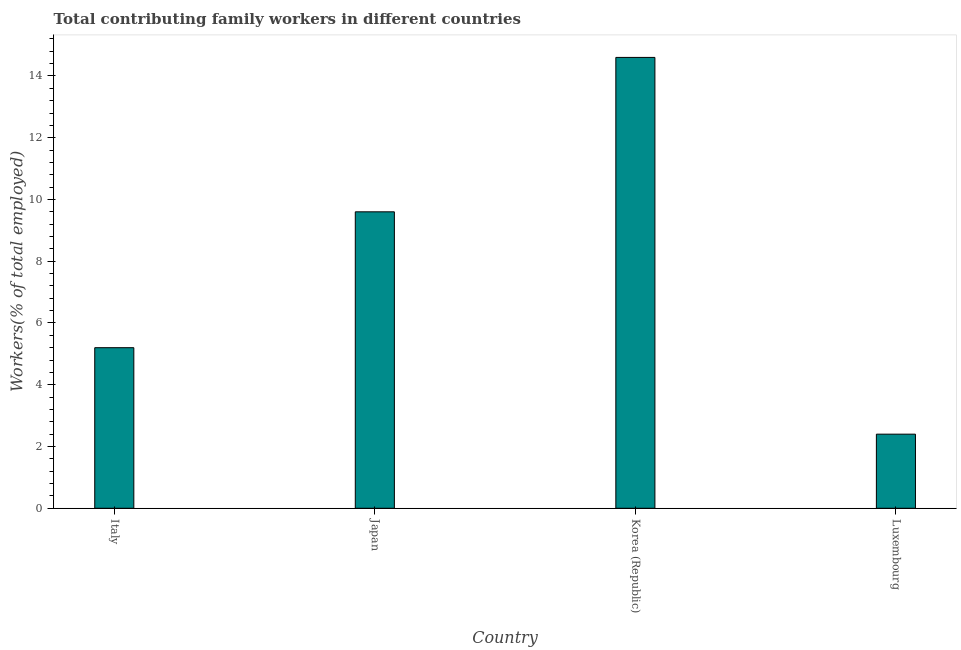Does the graph contain any zero values?
Keep it short and to the point. No. What is the title of the graph?
Offer a very short reply. Total contributing family workers in different countries. What is the label or title of the X-axis?
Give a very brief answer. Country. What is the label or title of the Y-axis?
Make the answer very short. Workers(% of total employed). What is the contributing family workers in Japan?
Your answer should be very brief. 9.6. Across all countries, what is the maximum contributing family workers?
Make the answer very short. 14.6. Across all countries, what is the minimum contributing family workers?
Make the answer very short. 2.4. In which country was the contributing family workers minimum?
Provide a succinct answer. Luxembourg. What is the sum of the contributing family workers?
Ensure brevity in your answer.  31.8. What is the average contributing family workers per country?
Keep it short and to the point. 7.95. What is the median contributing family workers?
Give a very brief answer. 7.4. What is the ratio of the contributing family workers in Italy to that in Japan?
Make the answer very short. 0.54. What is the difference between the highest and the second highest contributing family workers?
Your answer should be compact. 5. What is the difference between the highest and the lowest contributing family workers?
Your answer should be compact. 12.2. In how many countries, is the contributing family workers greater than the average contributing family workers taken over all countries?
Offer a very short reply. 2. How many bars are there?
Give a very brief answer. 4. Are all the bars in the graph horizontal?
Your answer should be very brief. No. How many countries are there in the graph?
Your answer should be very brief. 4. What is the Workers(% of total employed) of Italy?
Offer a very short reply. 5.2. What is the Workers(% of total employed) of Japan?
Offer a terse response. 9.6. What is the Workers(% of total employed) of Korea (Republic)?
Give a very brief answer. 14.6. What is the Workers(% of total employed) in Luxembourg?
Give a very brief answer. 2.4. What is the difference between the Workers(% of total employed) in Italy and Luxembourg?
Ensure brevity in your answer.  2.8. What is the difference between the Workers(% of total employed) in Japan and Luxembourg?
Your answer should be very brief. 7.2. What is the difference between the Workers(% of total employed) in Korea (Republic) and Luxembourg?
Provide a short and direct response. 12.2. What is the ratio of the Workers(% of total employed) in Italy to that in Japan?
Keep it short and to the point. 0.54. What is the ratio of the Workers(% of total employed) in Italy to that in Korea (Republic)?
Offer a very short reply. 0.36. What is the ratio of the Workers(% of total employed) in Italy to that in Luxembourg?
Ensure brevity in your answer.  2.17. What is the ratio of the Workers(% of total employed) in Japan to that in Korea (Republic)?
Keep it short and to the point. 0.66. What is the ratio of the Workers(% of total employed) in Japan to that in Luxembourg?
Offer a very short reply. 4. What is the ratio of the Workers(% of total employed) in Korea (Republic) to that in Luxembourg?
Offer a very short reply. 6.08. 